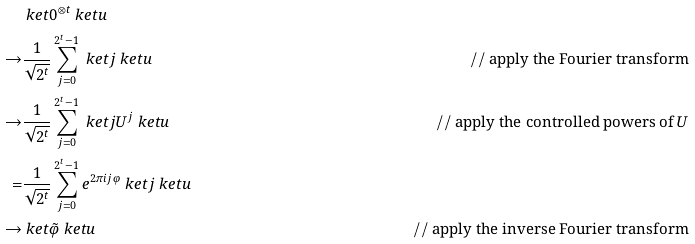<formula> <loc_0><loc_0><loc_500><loc_500>& \ k e t { 0 } ^ { \otimes t } \ k e t { u } \\ \rightarrow & \frac { 1 } { \sqrt { 2 ^ { t } } } \sum _ { j = 0 } ^ { 2 ^ { t } - 1 } \ k e t { j } \ k e t { u } & / / \text { apply the Fourier transform} \\ \rightarrow & \frac { 1 } { \sqrt { 2 ^ { t } } } \sum _ { j = 0 } ^ { 2 ^ { t } - 1 } \ k e t { j } U ^ { j } \ k e t { u } & / / \text { apply the controlled powers of $U$} \\ = & \frac { 1 } { \sqrt { 2 ^ { t } } } \sum _ { j = 0 } ^ { 2 ^ { t } - 1 } e ^ { 2 \pi i j \varphi } \ k e t { j } \ k e t { u } \\ \rightarrow & \ k e t { \tilde { \varphi } } \ k e t { u } & / / \text { apply the inverse Fourier transform}</formula> 